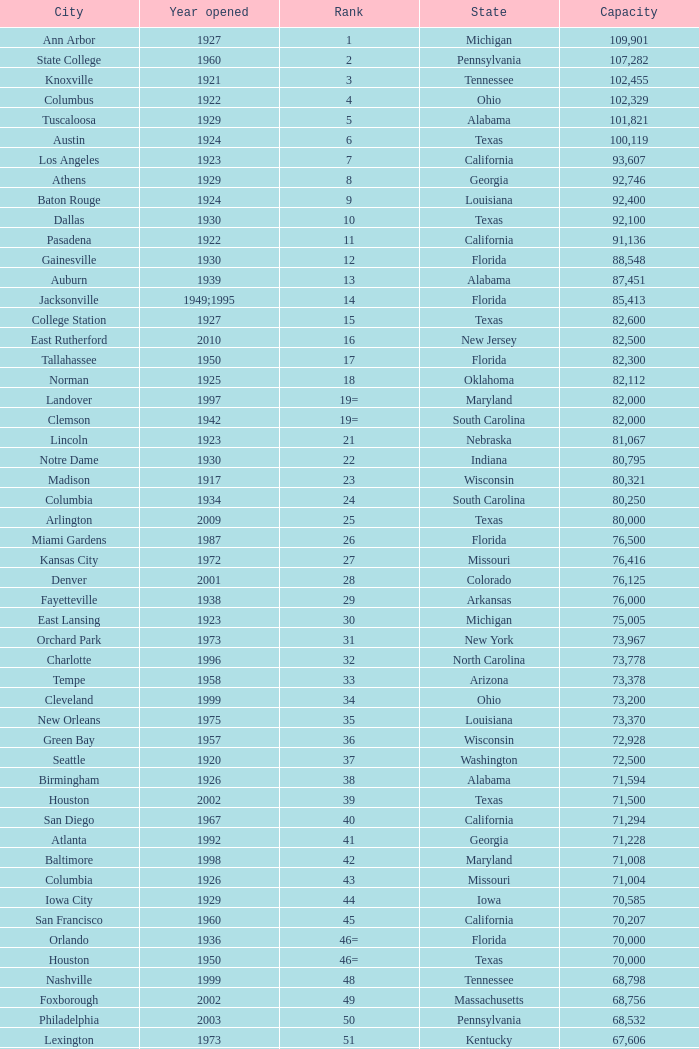What is the city in Alabama that opened in 1996? Huntsville. 